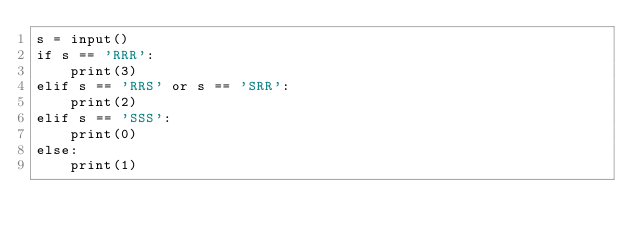Convert code to text. <code><loc_0><loc_0><loc_500><loc_500><_Python_>s = input()
if s == 'RRR':
    print(3)
elif s == 'RRS' or s == 'SRR':
    print(2)
elif s == 'SSS':
    print(0)
else:
    print(1)</code> 